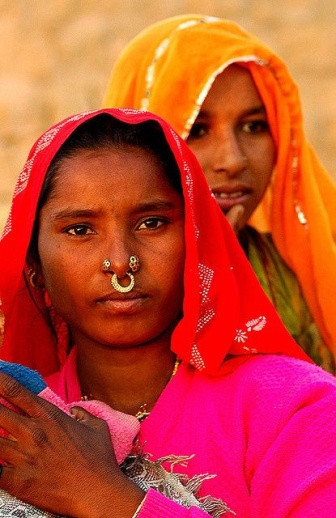Imagine a story inspired by the image. In a small, sun-kissed village nestled at the edge of a vast desert, two sisters stand as guardians of their family’s legacy. The elder sister, Rina, wears a pink sari and a radiant gold nose ring passed down from their grandmother. Her younger sister, Anaya, dressed in a vibrant orange sari, often dreams of the world beyond the sand dunes. Together, they weave stories of their ancestors, preserving the tales of bravery, love, and wisdom. Each day, Rina and Anaya perform traditional dances at dusk, their graceful movements telling tales as old as time, their attires adding color to the monochrome sands. The villagers gather to watch, celebrating their heritage and the bond between the sisters. 